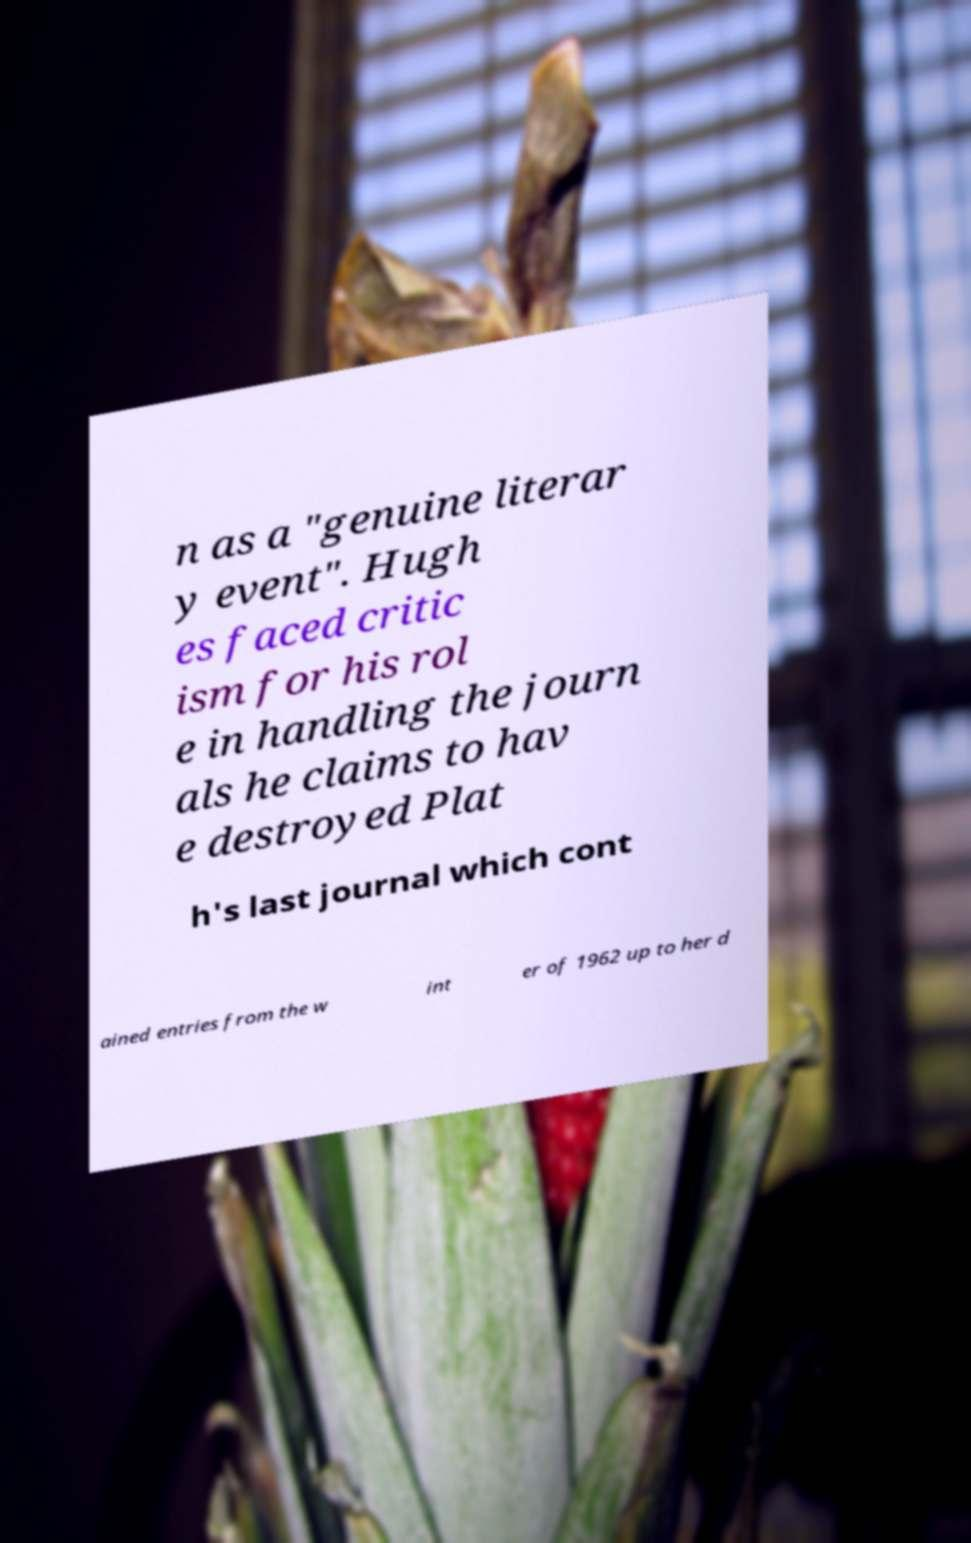There's text embedded in this image that I need extracted. Can you transcribe it verbatim? n as a "genuine literar y event". Hugh es faced critic ism for his rol e in handling the journ als he claims to hav e destroyed Plat h's last journal which cont ained entries from the w int er of 1962 up to her d 